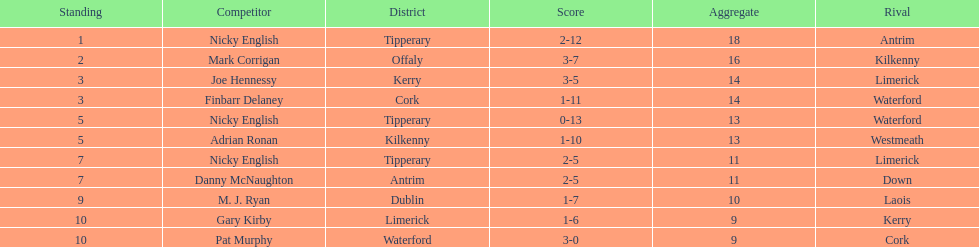Who was the top ranked player in a single game? Nicky English. 